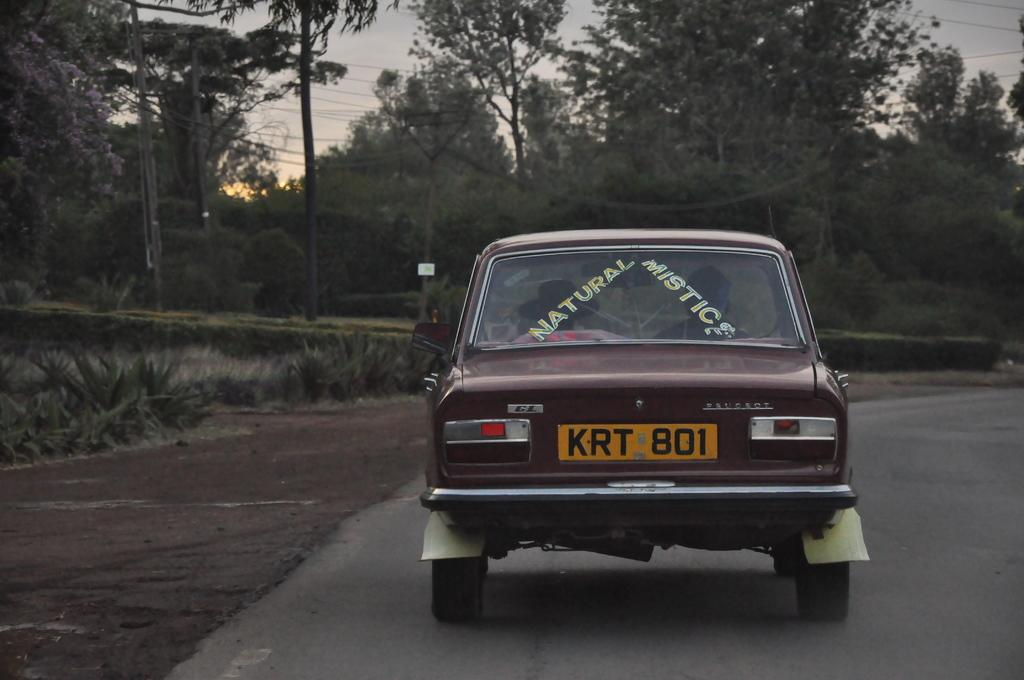What is the main subject of the image? The main subject of the image is a car. Where is the car located in the image? The car is on the road in the image. What can be seen in the background of the image? In the background of the image, there are trees, plants, wires, and the sky. How many pizzas are being delivered by the boats in the image? There are no boats or pizzas present in the image; it features a car on the road with a background of trees, plants, wires, and the sky. 